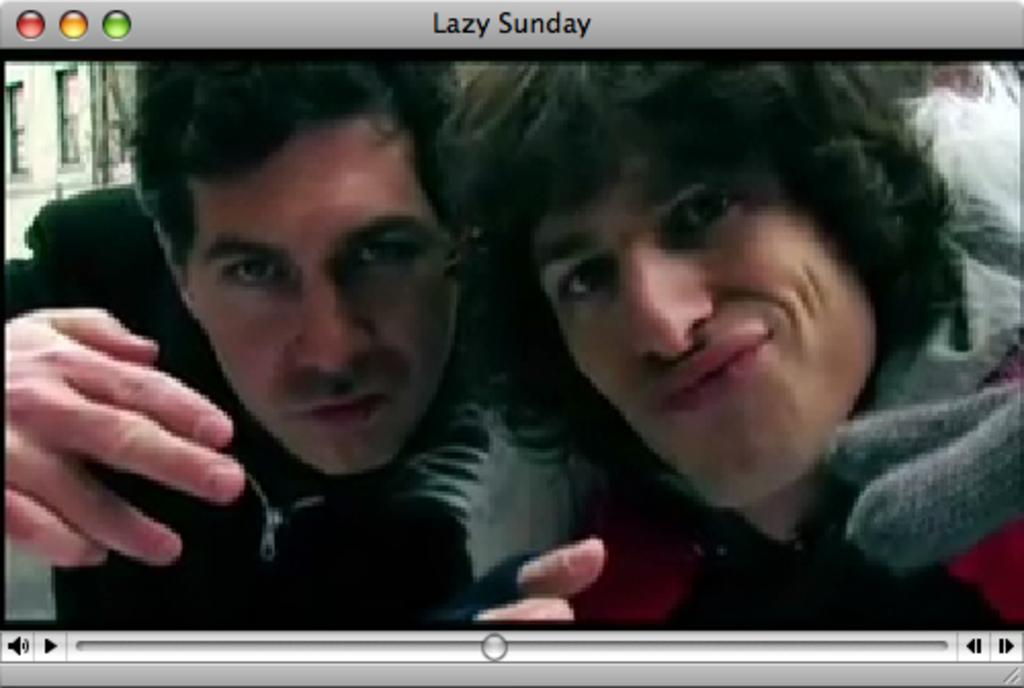How many people are present in the image? There are two persons in the image. What type of stretch is the person on the left performing in the image? There is no stretch being performed in the image; it only shows two persons. 